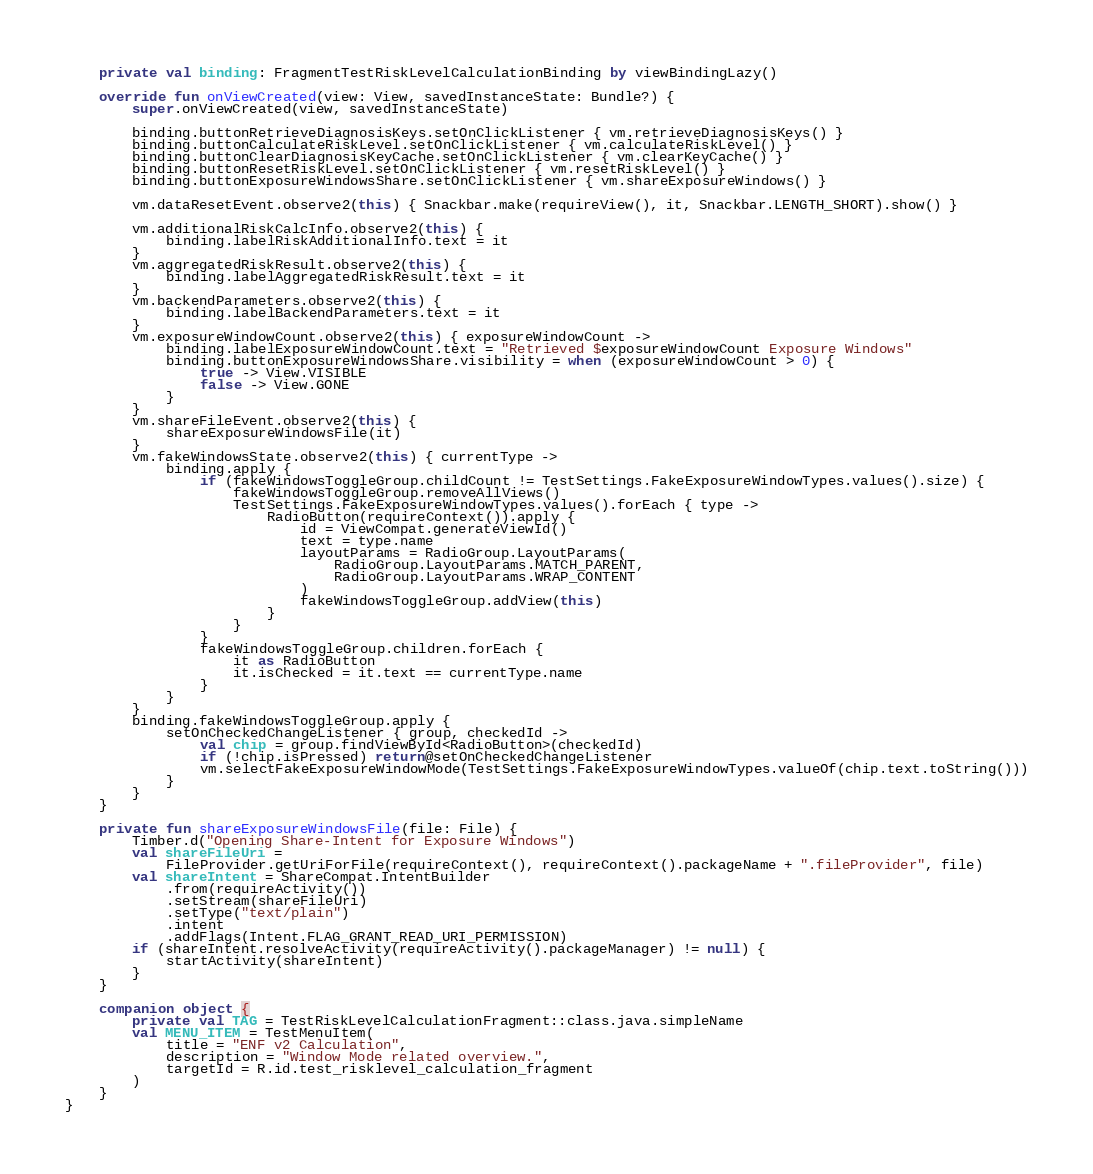<code> <loc_0><loc_0><loc_500><loc_500><_Kotlin_>
    private val binding: FragmentTestRiskLevelCalculationBinding by viewBindingLazy()

    override fun onViewCreated(view: View, savedInstanceState: Bundle?) {
        super.onViewCreated(view, savedInstanceState)

        binding.buttonRetrieveDiagnosisKeys.setOnClickListener { vm.retrieveDiagnosisKeys() }
        binding.buttonCalculateRiskLevel.setOnClickListener { vm.calculateRiskLevel() }
        binding.buttonClearDiagnosisKeyCache.setOnClickListener { vm.clearKeyCache() }
        binding.buttonResetRiskLevel.setOnClickListener { vm.resetRiskLevel() }
        binding.buttonExposureWindowsShare.setOnClickListener { vm.shareExposureWindows() }

        vm.dataResetEvent.observe2(this) { Snackbar.make(requireView(), it, Snackbar.LENGTH_SHORT).show() }

        vm.additionalRiskCalcInfo.observe2(this) {
            binding.labelRiskAdditionalInfo.text = it
        }
        vm.aggregatedRiskResult.observe2(this) {
            binding.labelAggregatedRiskResult.text = it
        }
        vm.backendParameters.observe2(this) {
            binding.labelBackendParameters.text = it
        }
        vm.exposureWindowCount.observe2(this) { exposureWindowCount ->
            binding.labelExposureWindowCount.text = "Retrieved $exposureWindowCount Exposure Windows"
            binding.buttonExposureWindowsShare.visibility = when (exposureWindowCount > 0) {
                true -> View.VISIBLE
                false -> View.GONE
            }
        }
        vm.shareFileEvent.observe2(this) {
            shareExposureWindowsFile(it)
        }
        vm.fakeWindowsState.observe2(this) { currentType ->
            binding.apply {
                if (fakeWindowsToggleGroup.childCount != TestSettings.FakeExposureWindowTypes.values().size) {
                    fakeWindowsToggleGroup.removeAllViews()
                    TestSettings.FakeExposureWindowTypes.values().forEach { type ->
                        RadioButton(requireContext()).apply {
                            id = ViewCompat.generateViewId()
                            text = type.name
                            layoutParams = RadioGroup.LayoutParams(
                                RadioGroup.LayoutParams.MATCH_PARENT,
                                RadioGroup.LayoutParams.WRAP_CONTENT
                            )
                            fakeWindowsToggleGroup.addView(this)
                        }
                    }
                }
                fakeWindowsToggleGroup.children.forEach {
                    it as RadioButton
                    it.isChecked = it.text == currentType.name
                }
            }
        }
        binding.fakeWindowsToggleGroup.apply {
            setOnCheckedChangeListener { group, checkedId ->
                val chip = group.findViewById<RadioButton>(checkedId)
                if (!chip.isPressed) return@setOnCheckedChangeListener
                vm.selectFakeExposureWindowMode(TestSettings.FakeExposureWindowTypes.valueOf(chip.text.toString()))
            }
        }
    }

    private fun shareExposureWindowsFile(file: File) {
        Timber.d("Opening Share-Intent for Exposure Windows")
        val shareFileUri =
            FileProvider.getUriForFile(requireContext(), requireContext().packageName + ".fileProvider", file)
        val shareIntent = ShareCompat.IntentBuilder
            .from(requireActivity())
            .setStream(shareFileUri)
            .setType("text/plain")
            .intent
            .addFlags(Intent.FLAG_GRANT_READ_URI_PERMISSION)
        if (shareIntent.resolveActivity(requireActivity().packageManager) != null) {
            startActivity(shareIntent)
        }
    }

    companion object {
        private val TAG = TestRiskLevelCalculationFragment::class.java.simpleName
        val MENU_ITEM = TestMenuItem(
            title = "ENF v2 Calculation",
            description = "Window Mode related overview.",
            targetId = R.id.test_risklevel_calculation_fragment
        )
    }
}
</code> 